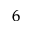<formula> <loc_0><loc_0><loc_500><loc_500>_ { 6 }</formula> 